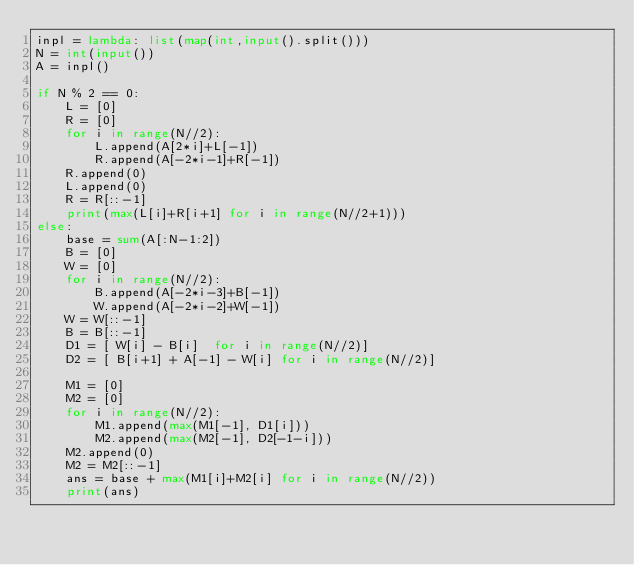<code> <loc_0><loc_0><loc_500><loc_500><_Python_>inpl = lambda: list(map(int,input().split()))
N = int(input())
A = inpl()

if N % 2 == 0:
    L = [0]
    R = [0]
    for i in range(N//2):
        L.append(A[2*i]+L[-1])
        R.append(A[-2*i-1]+R[-1])
    R.append(0)
    L.append(0)
    R = R[::-1]
    print(max(L[i]+R[i+1] for i in range(N//2+1)))
else:
    base = sum(A[:N-1:2])
    B = [0]
    W = [0]
    for i in range(N//2):
        B.append(A[-2*i-3]+B[-1])
        W.append(A[-2*i-2]+W[-1])
    W = W[::-1]
    B = B[::-1]
    D1 = [ W[i] - B[i]  for i in range(N//2)]
    D2 = [ B[i+1] + A[-1] - W[i] for i in range(N//2)]

    M1 = [0]
    M2 = [0]
    for i in range(N//2):
        M1.append(max(M1[-1], D1[i]))
        M2.append(max(M2[-1], D2[-1-i]))
    M2.append(0)
    M2 = M2[::-1]
    ans = base + max(M1[i]+M2[i] for i in range(N//2))
    print(ans)
</code> 